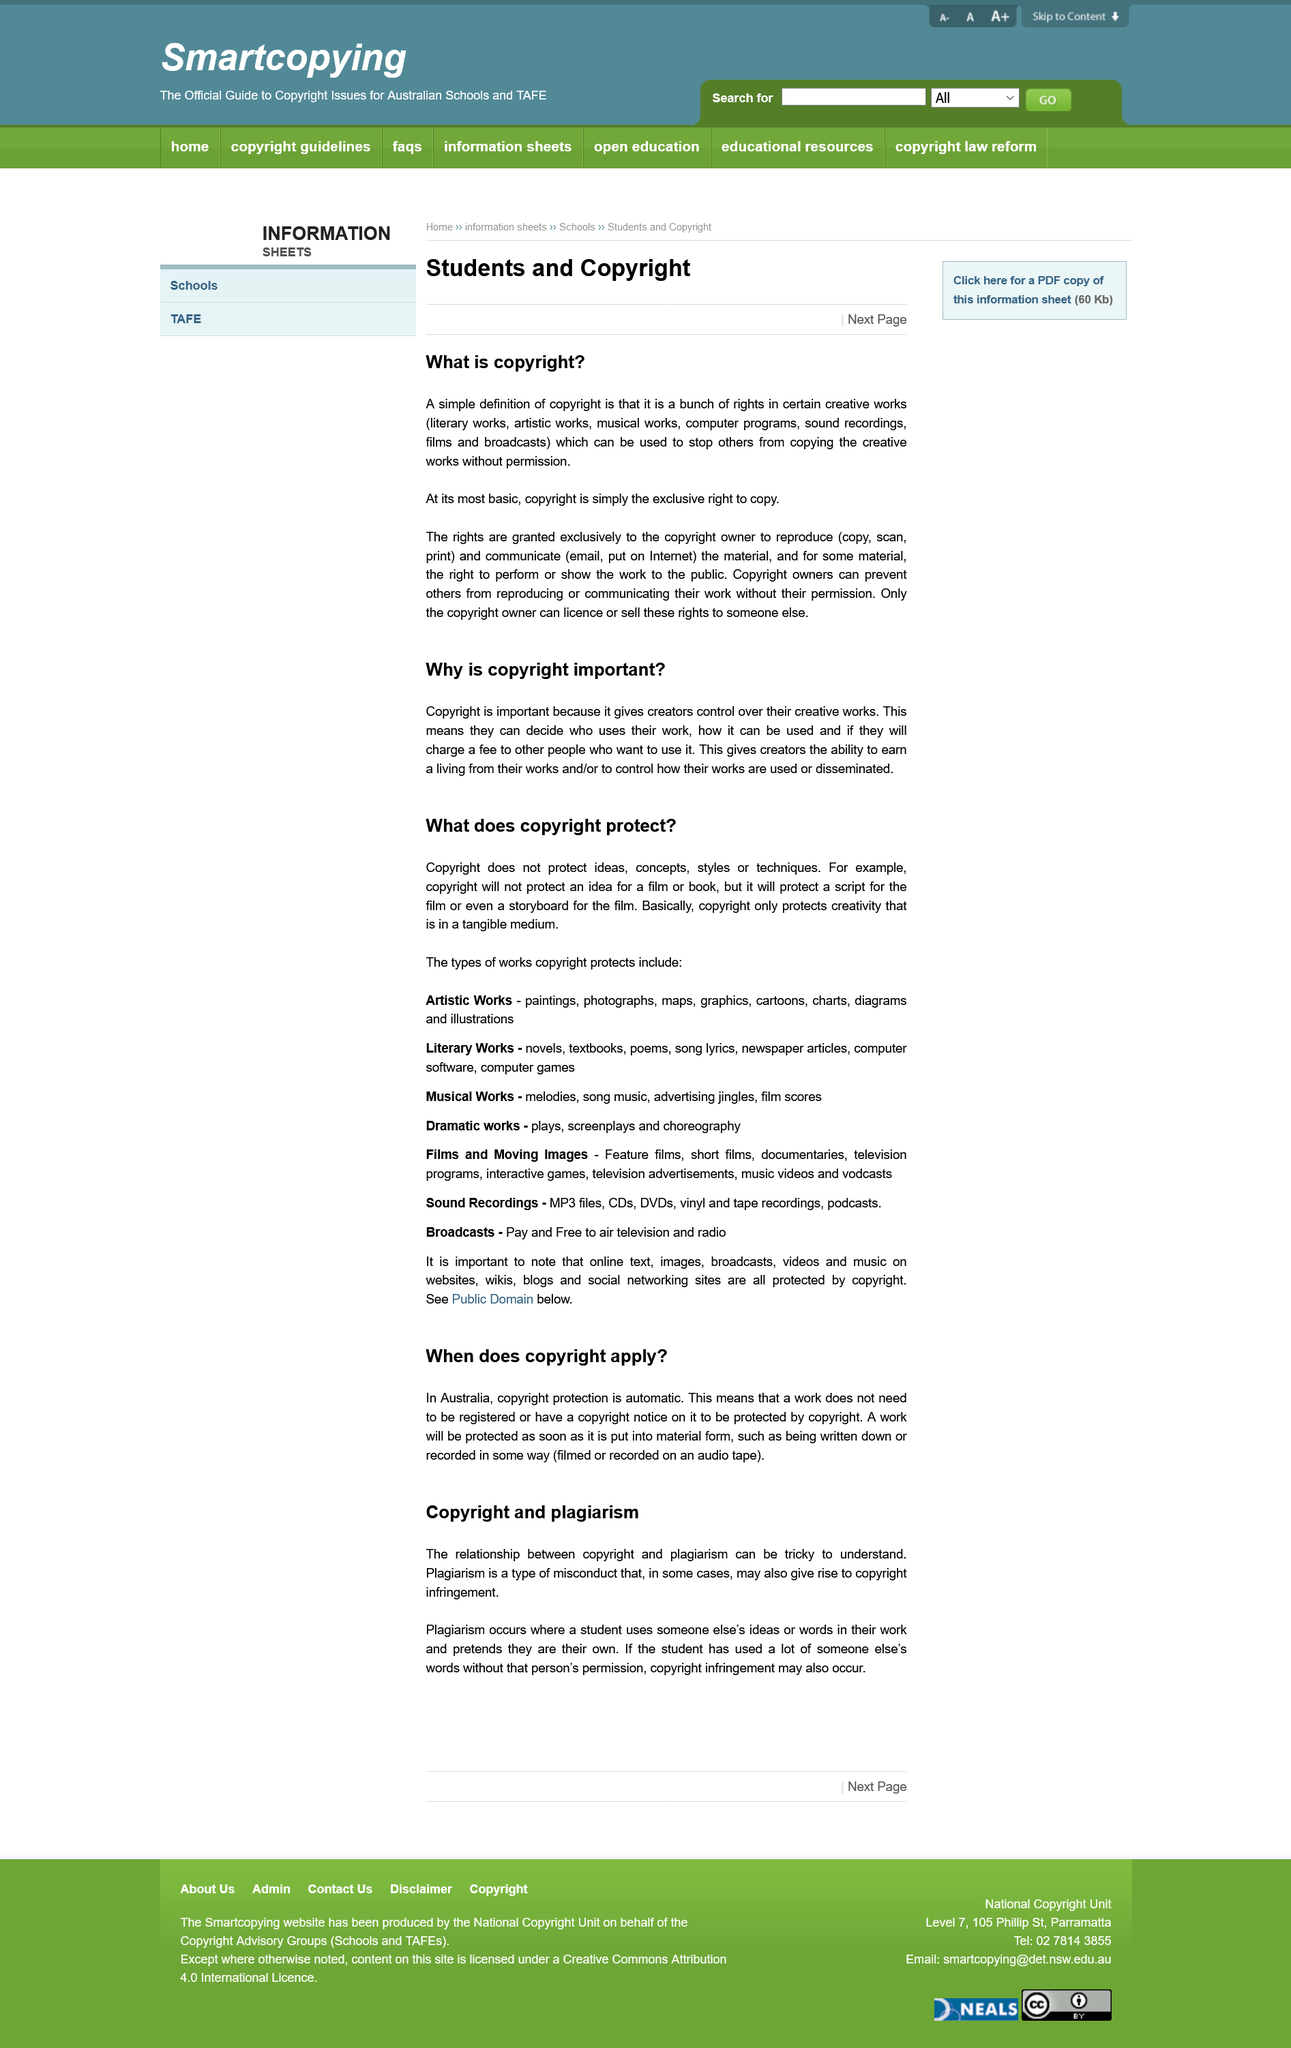Indicate a few pertinent items in this graphic. Declarative sentence: Dramatic works, including plays, screenplays, and choreography, are considered to be types of works. The first question is "What is copyright? Plagiarism occurs when a student uses someone else's ideas or words in their work and pretends they are their own. The relationship between copyright and plagiarism can be tricky to understand. According to the article "Copyright and plagiarism", copyright protection in Australia is automatic, as the moment a work is created and fixed in a tangible form, it is automatically protected by copyright law. 